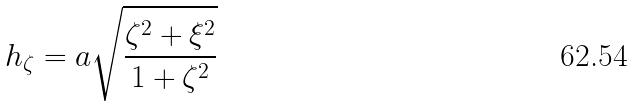<formula> <loc_0><loc_0><loc_500><loc_500>h _ { \zeta } = a \sqrt { \frac { \zeta ^ { 2 } + \xi ^ { 2 } } { 1 + \zeta ^ { 2 } } }</formula> 